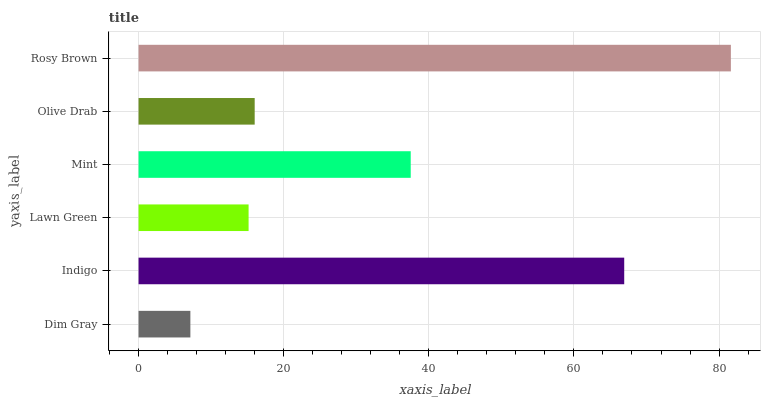Is Dim Gray the minimum?
Answer yes or no. Yes. Is Rosy Brown the maximum?
Answer yes or no. Yes. Is Indigo the minimum?
Answer yes or no. No. Is Indigo the maximum?
Answer yes or no. No. Is Indigo greater than Dim Gray?
Answer yes or no. Yes. Is Dim Gray less than Indigo?
Answer yes or no. Yes. Is Dim Gray greater than Indigo?
Answer yes or no. No. Is Indigo less than Dim Gray?
Answer yes or no. No. Is Mint the high median?
Answer yes or no. Yes. Is Olive Drab the low median?
Answer yes or no. Yes. Is Dim Gray the high median?
Answer yes or no. No. Is Dim Gray the low median?
Answer yes or no. No. 